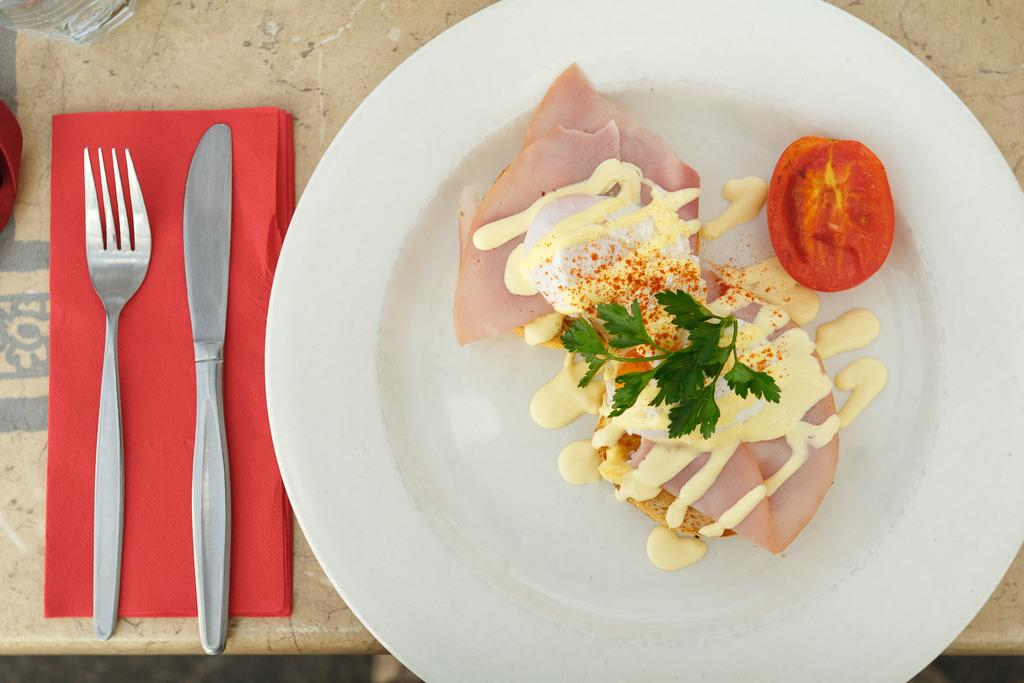What is on the plate that is visible in the image? There are food items on a plate in the image. What utensils are present in the image? There is a knife and a fork in the image. Where are the knife and fork placed? The knife and fork are on a cloth in the image. On what surface are the plate, knife, fork, and cloth located? The plate, knife, fork, and cloth are on a table in the image. What type of pest can be seen crawling on the brother's arm in the image? There is no brother or pest present in the image. 